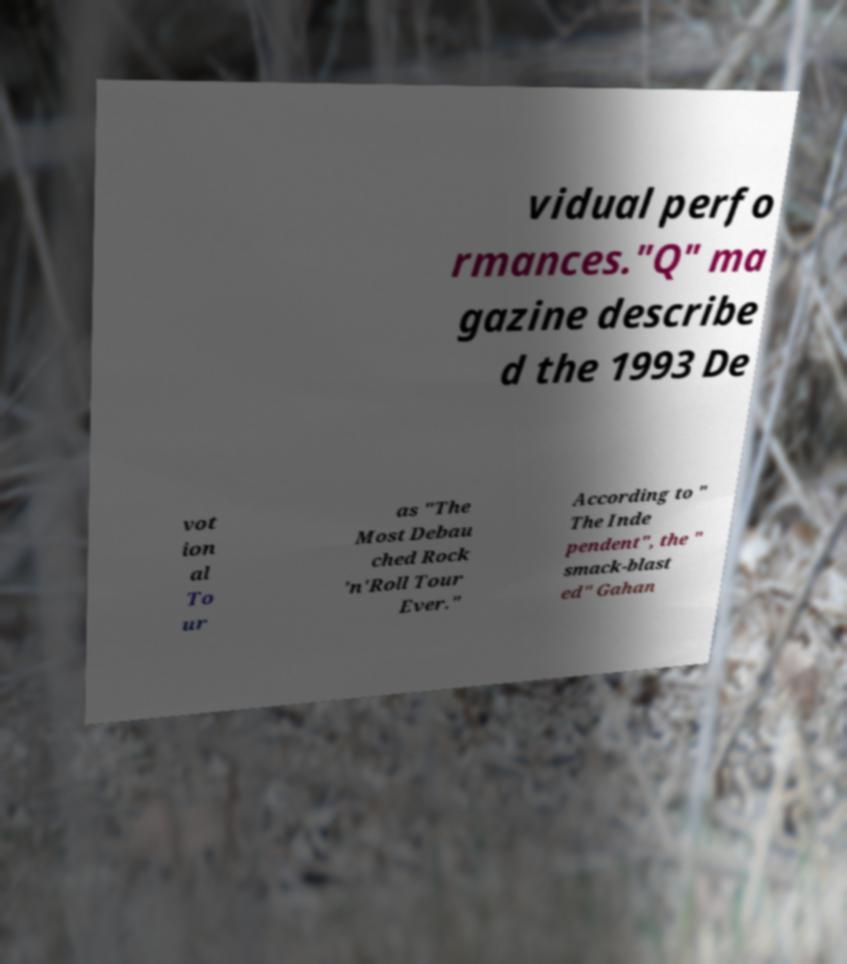Could you extract and type out the text from this image? vidual perfo rmances."Q" ma gazine describe d the 1993 De vot ion al To ur as "The Most Debau ched Rock 'n'Roll Tour Ever." According to " The Inde pendent", the " smack-blast ed" Gahan 